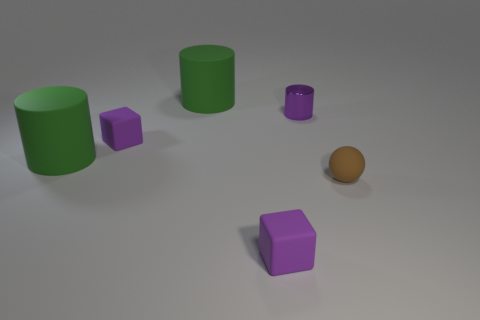What number of other things are the same size as the sphere?
Your answer should be compact. 3. How many green things are small things or matte cylinders?
Ensure brevity in your answer.  2. There is a purple matte block in front of the small sphere; what number of small cubes are on the left side of it?
Make the answer very short. 1. Is there anything else that has the same color as the metallic cylinder?
Ensure brevity in your answer.  Yes. Does the small block that is in front of the brown rubber object have the same material as the cube that is behind the brown rubber object?
Provide a succinct answer. Yes. How many objects are either tiny yellow cylinders or purple blocks in front of the small matte sphere?
Provide a succinct answer. 1. Are there any other things that have the same material as the small purple cylinder?
Your answer should be very brief. No. What material is the tiny brown thing?
Offer a terse response. Rubber. Is the tiny purple cylinder made of the same material as the sphere?
Keep it short and to the point. No. What number of metal things are small cyan objects or purple cubes?
Ensure brevity in your answer.  0. 